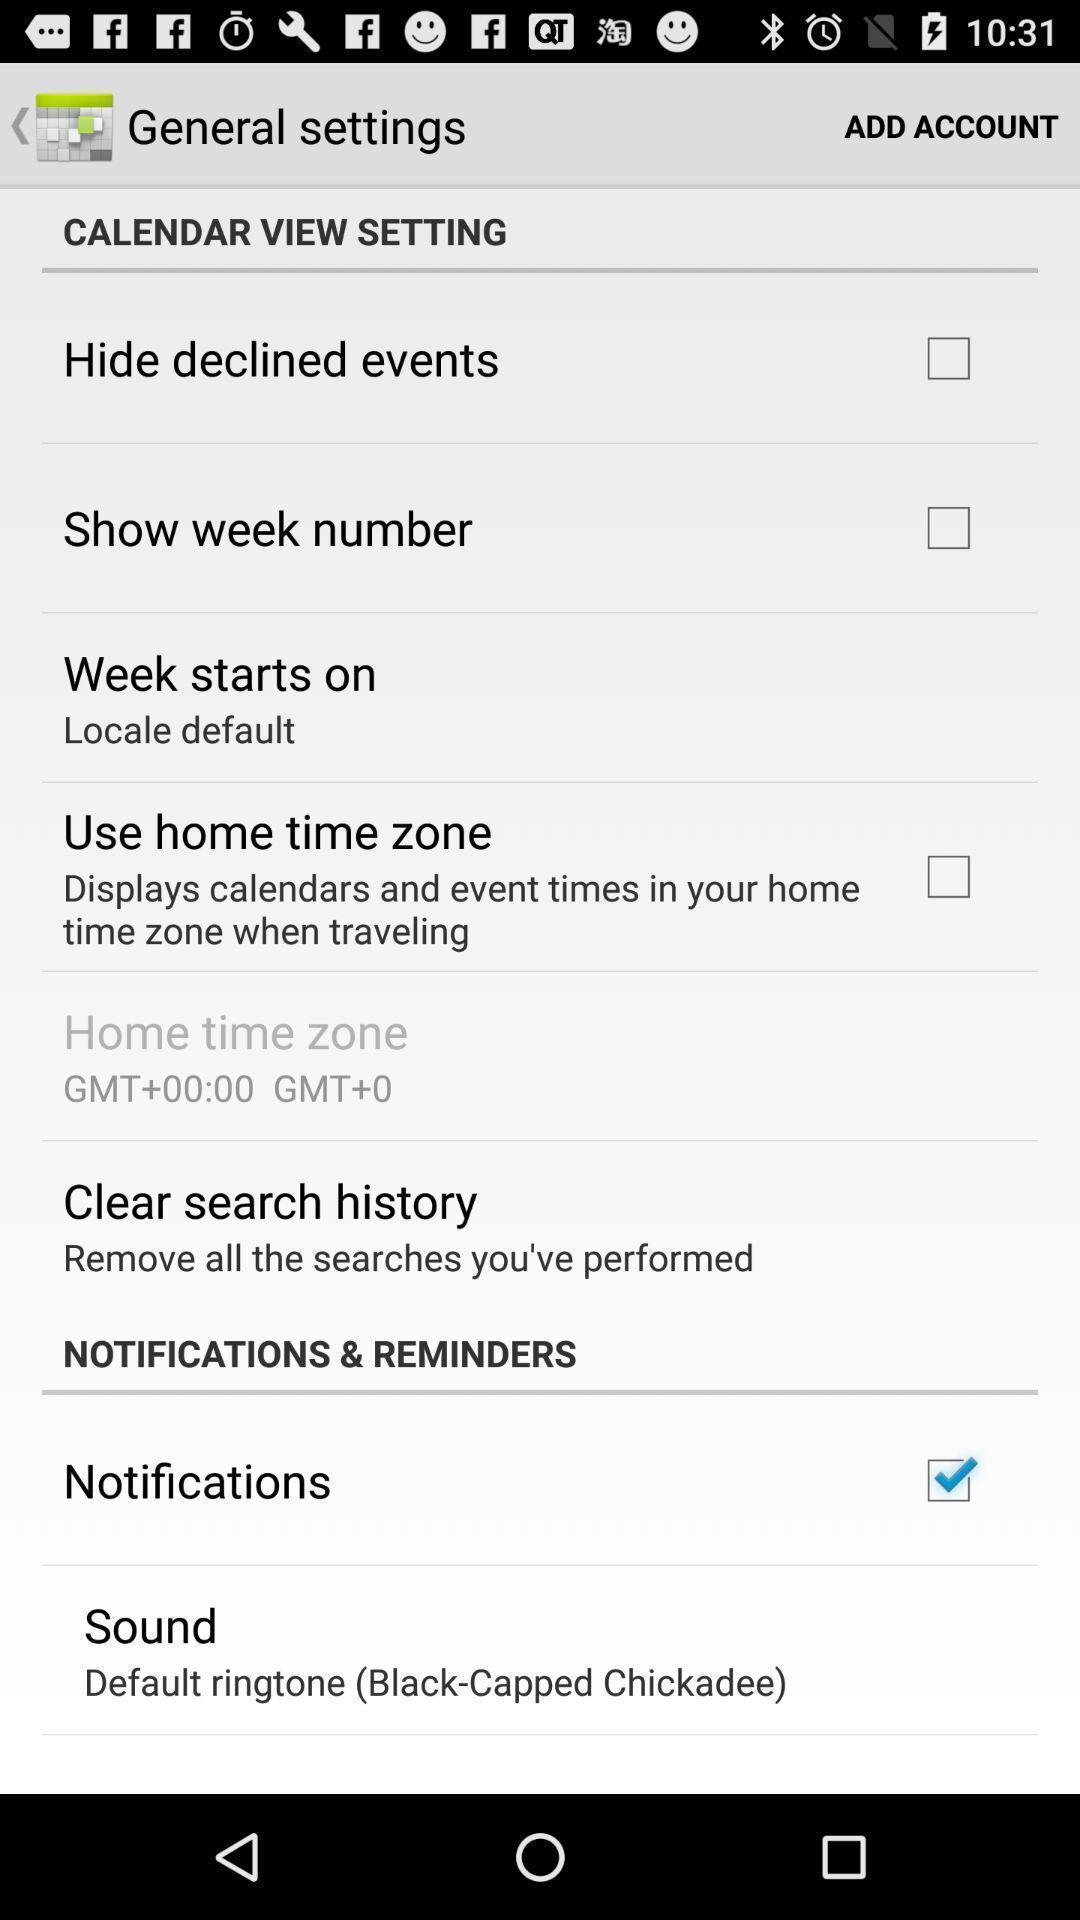Describe the key features of this screenshot. Settings page with some other options. 